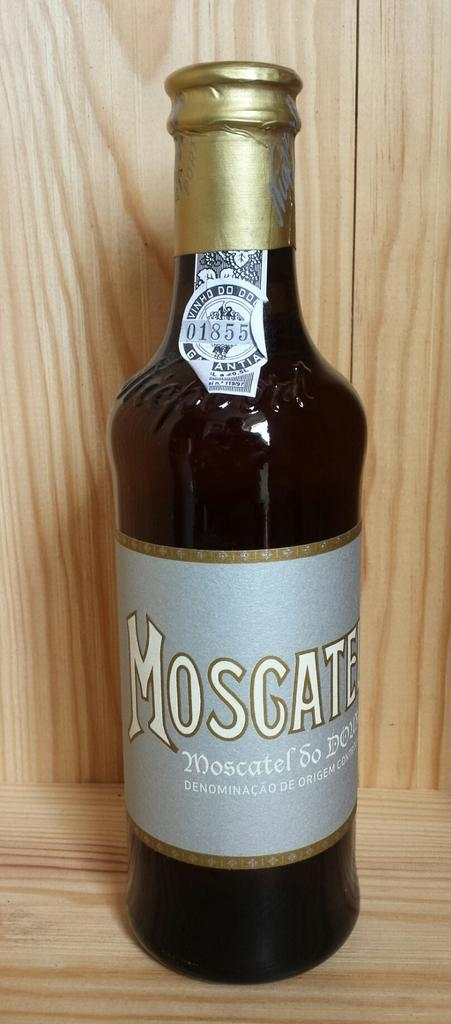<image>
Offer a succinct explanation of the picture presented. Bottle of Mosgate sits alone on a wooden shelf. 